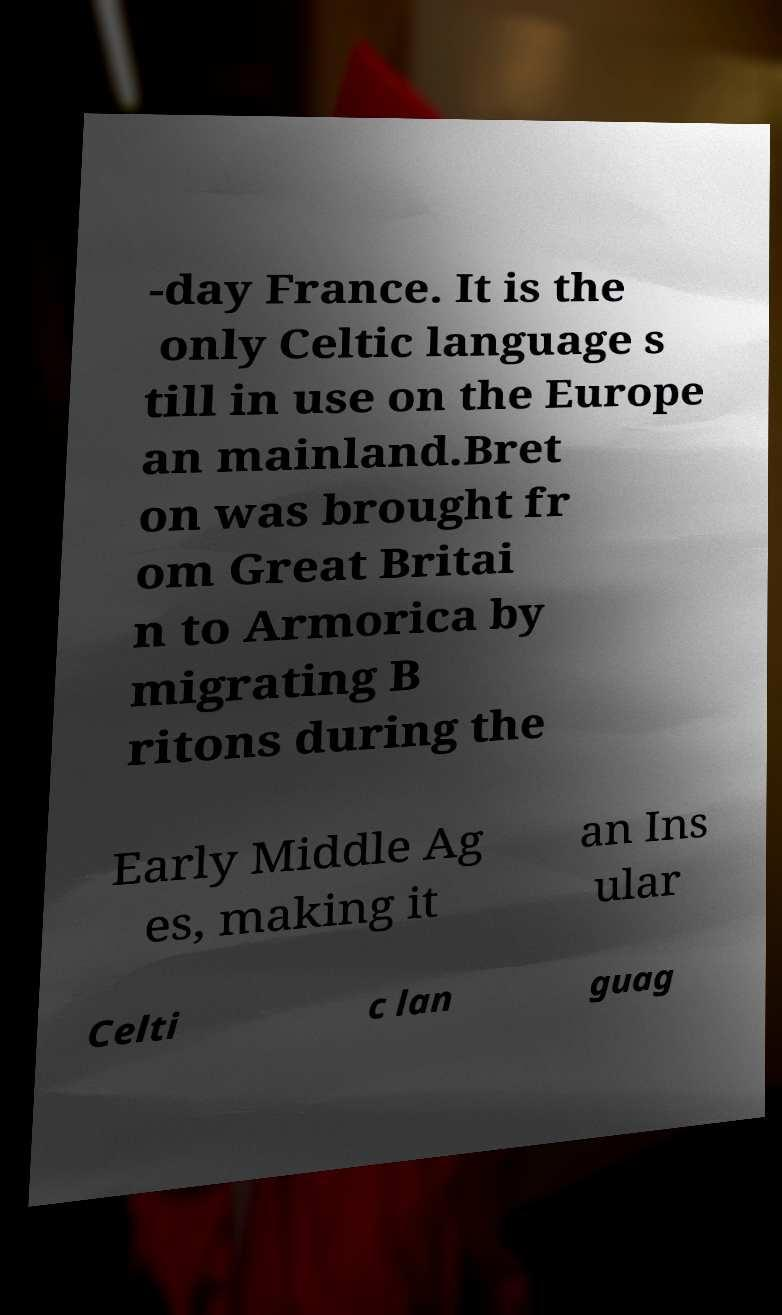For documentation purposes, I need the text within this image transcribed. Could you provide that? -day France. It is the only Celtic language s till in use on the Europe an mainland.Bret on was brought fr om Great Britai n to Armorica by migrating B ritons during the Early Middle Ag es, making it an Ins ular Celti c lan guag 